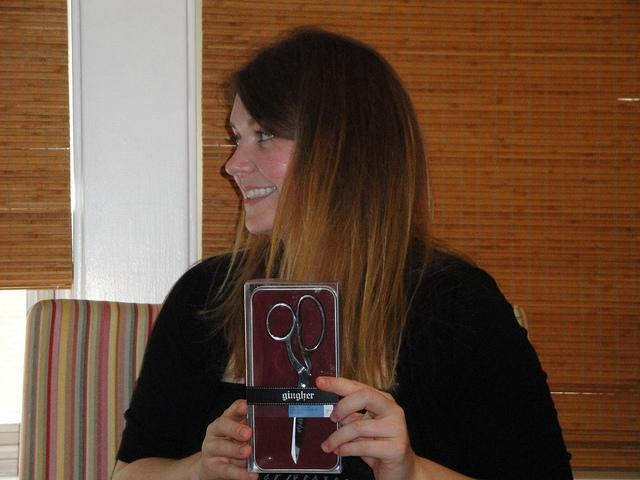What is the design of the chair?

Choices:
A) dotted
B) striped
C) checkered
D) solid striped 